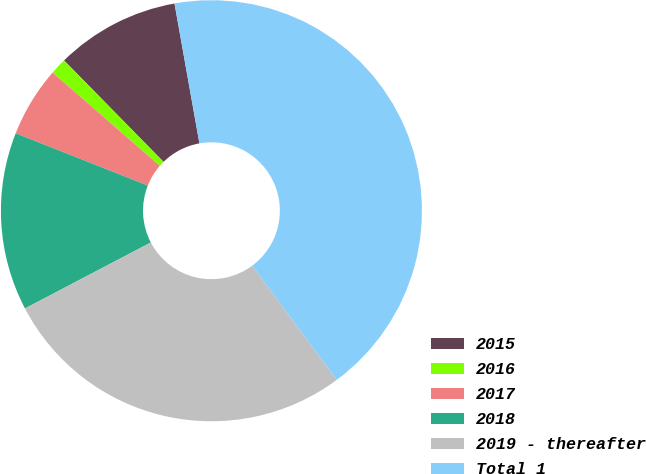Convert chart. <chart><loc_0><loc_0><loc_500><loc_500><pie_chart><fcel>2015<fcel>2016<fcel>2017<fcel>2018<fcel>2019 - thereafter<fcel>Total 1<nl><fcel>9.54%<fcel>1.26%<fcel>5.4%<fcel>13.68%<fcel>27.47%<fcel>42.66%<nl></chart> 